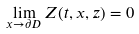Convert formula to latex. <formula><loc_0><loc_0><loc_500><loc_500>\lim _ { x \rightarrow \partial D } Z ( t , x , z ) = 0</formula> 